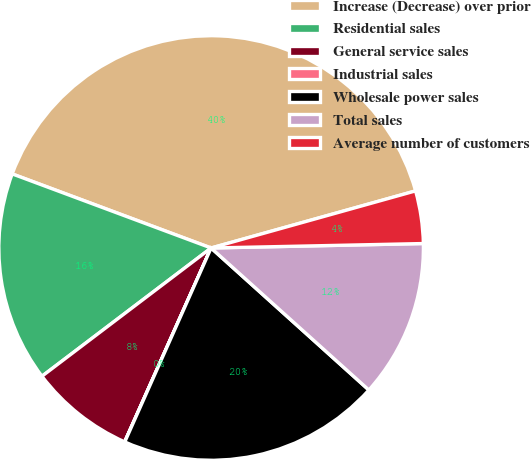Convert chart to OTSL. <chart><loc_0><loc_0><loc_500><loc_500><pie_chart><fcel>Increase (Decrease) over prior<fcel>Residential sales<fcel>General service sales<fcel>Industrial sales<fcel>Wholesale power sales<fcel>Total sales<fcel>Average number of customers<nl><fcel>39.99%<fcel>16.0%<fcel>8.0%<fcel>0.01%<fcel>20.0%<fcel>12.0%<fcel>4.0%<nl></chart> 